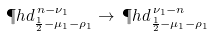Convert formula to latex. <formula><loc_0><loc_0><loc_500><loc_500>\P h d ^ { \, n - \nu _ { 1 } } _ { \frac { 1 } { 2 } - \mu _ { 1 } - \rho _ { 1 } } \to \, \P h d ^ { \, \nu _ { 1 } - n } _ { \frac { 1 } { 2 } - \mu _ { 1 } - \rho _ { 1 } }</formula> 